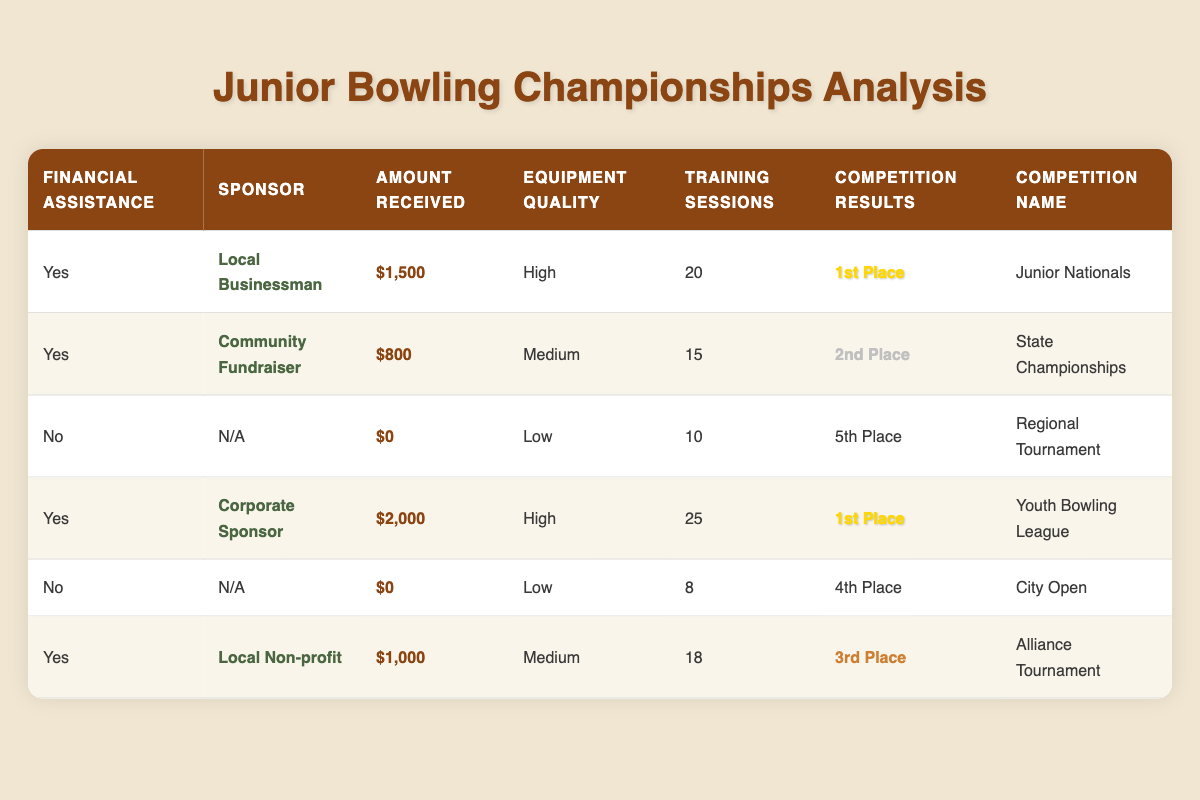What is the total amount of financial assistance received by bowlers? The table shows assistance amounts of $1,500, $800, $2,000, and $1,000 from four bowlers receiving financial support. Summing these amounts: $1,500 + $800 + $2,000 + $1,000 = $5,300.
Answer: $5,300 Which bowler received the highest amount of financial assistance? The amounts received by each bowler are $1,500, $800, $0, $2,000, $0, and $1,000. The highest amount is $2,000 from the Corporate Sponsor.
Answer: $2,000 Did any bowler without financial assistance achieve 1st Place in their competition? From the table, those without financial assistance placed 5th and 4th. Since there is no 1st Place finish mentioned for them, the answer is no.
Answer: No What was the average number of training sessions for bowlers who received financial assistance? The bowlers receiving assistance had training sessions of 20, 15, 25, and 18. The sum is 20 + 15 + 25 + 18 = 78. There are 4 bowlers, so the average is 78/4 = 19.5.
Answer: 19.5 Is the statement true that all bowlers with high-quality equipment placed in the top three? The table shows that two bowlers with high-quality equipment placed 1st, while another placed 1st, and one with medium equipment placed 2nd, making the statement partially true.
Answer: False Which competition had the best result achieved by a bowler who did not receive financial assistance? The bowlers without financial assistance finished 5th and 4th. Thus, the best result is 4th Place in the City Open.
Answer: 4th Place What percentage of bowlers finished in the top three who received financial assistance? Four bowlers received assistance, and two of them finished in the top three (1st, 2nd, and 3rd). The calculation for percentage is (2/4) * 100 = 50%.
Answer: 50% What is the difference in training sessions between the bowler with the highest financial assistance and the one with the lowest? The bowler with the highest assistance had 25 training sessions, and the lowest (those without assistance) had 8 training sessions. The difference is 25 - 8 = 17.
Answer: 17 How many bowlers positioned 4th or lower received financial assistance? The table shows that one bowler with assistance placed 3rd and another without assistance placed 4th and 5th. Therefore, there are no bowlers with assistance below 4th place.
Answer: 0 